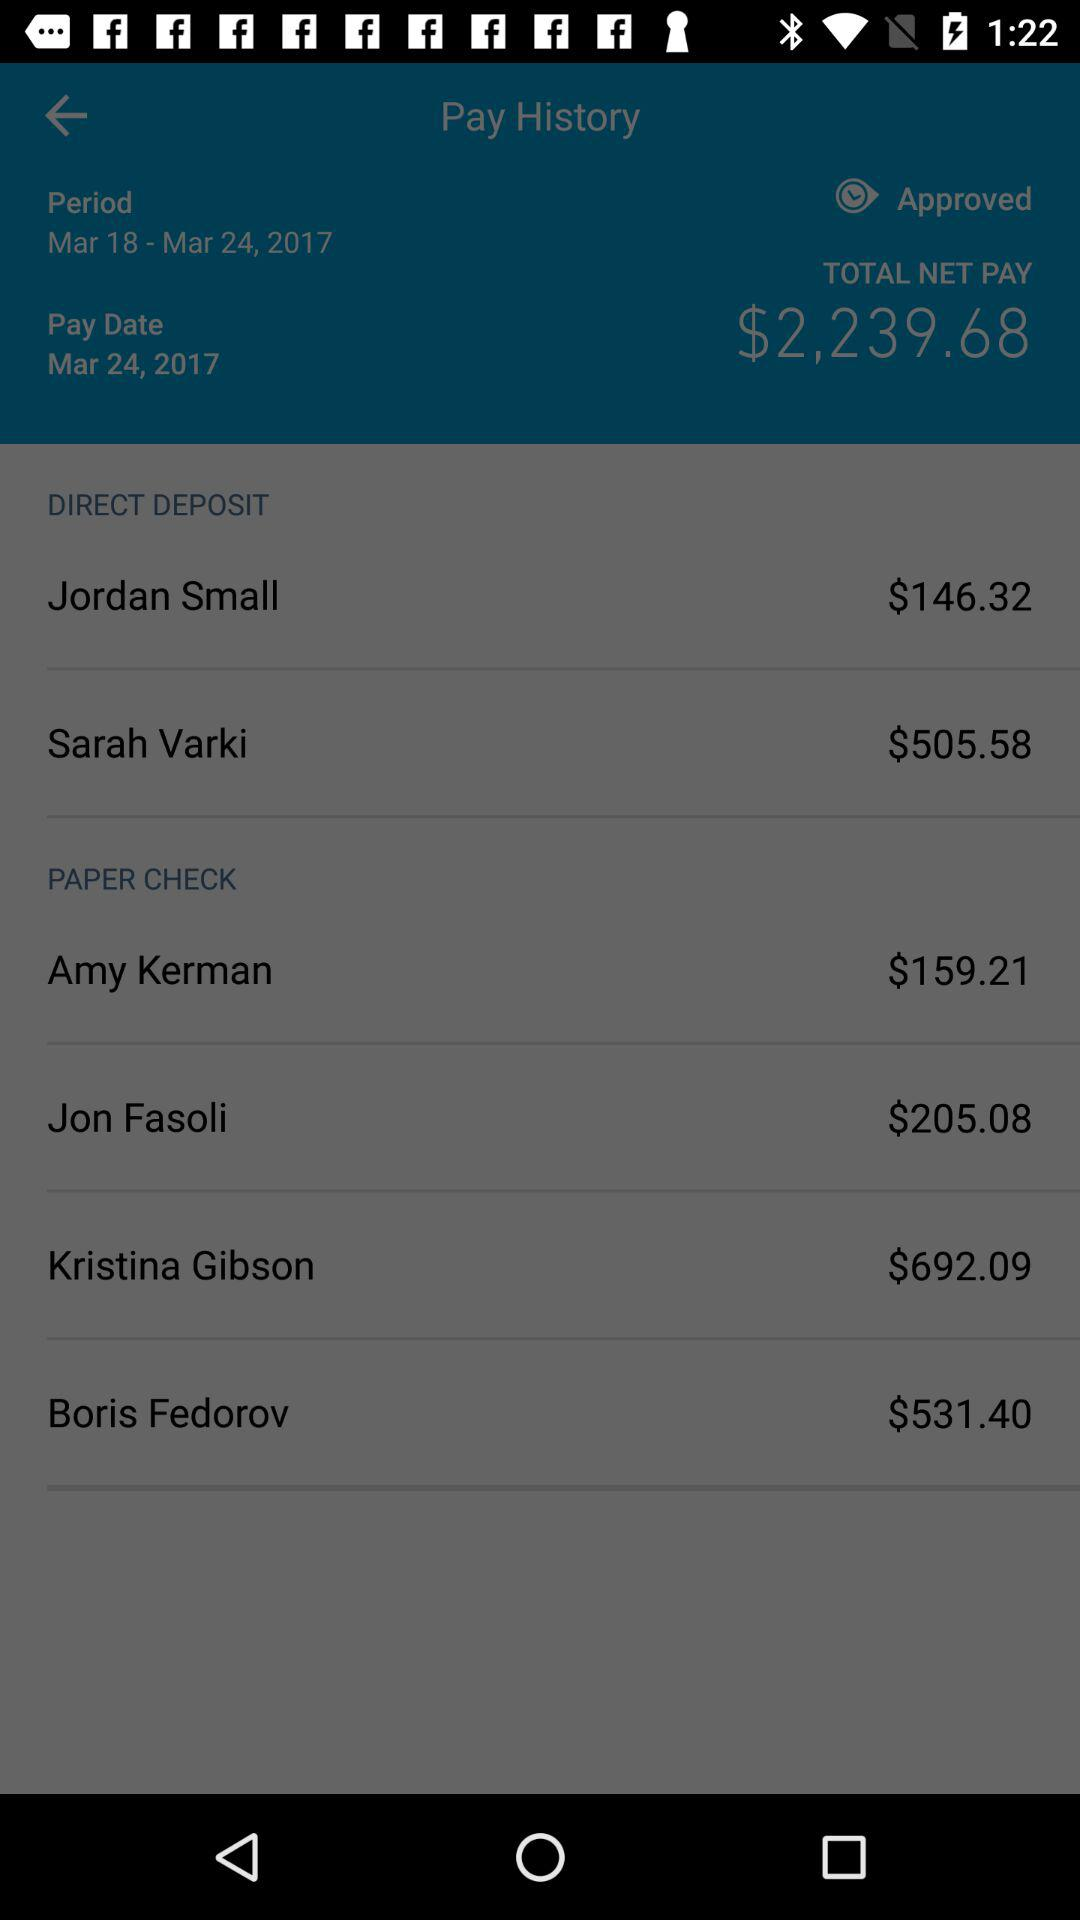What is the total amount of money paid to employees?
Answer the question using a single word or phrase. $2,239.68 